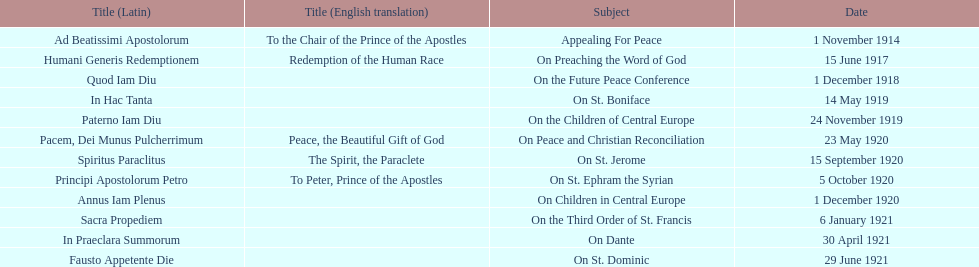After 1 december 1918 when was the next encyclical? 14 May 1919. 